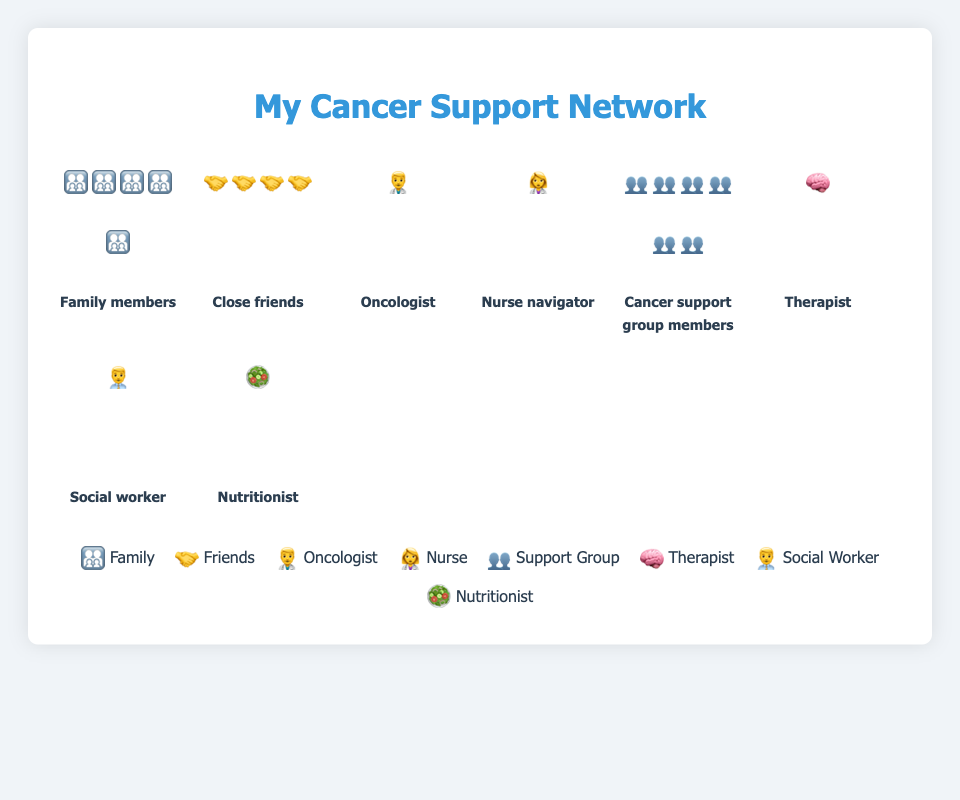How many family members are depicted in the plot? The plot shows five icons representing family members. You can count the icons labeled under "Family members."
Answer: 5 Which support network type has the highest count? By looking at the isotype plot, the "Cancer support group members" category has six icons, which is the highest count compared to other support types.
Answer: Cancer support group members What is the combined count of professional healthcare providers (Oncologist, Nurse navigator, Therapist, Social worker, Nutritionist)? Add the counts from the categories of Oncologist (1), Nurse navigator (1), Therapist (1), Social worker (1), and Nutritionist (1). 1 + 1 + 1 + 1 + 1 = 5.
Answer: 5 How does the number of close friends compare to family members? The figure shows four icons for close friends and five icons for family members. Since 4 < 5, there are fewer close friends than family members.
Answer: Fewer Which category has an equal number of icons to the Oncologist? Both the "Nurse navigator," the "Therapist," the "Social worker," and the "Nutritionist" categories have one icon each, which is equal to the icon count for "Oncologist."
Answer: Nurse navigator, Therapist, Social worker, Nutritionist How many support types have only one member depicted? By counting how many categories have one icon each, we find the Oncologist, Nurse navigator, Therapist, Social worker, and Nutritionist, making a total of 5 support types.
Answer: 5 What's the total number of icons present in the plot? Sum all icons across all categories: Family members (5) + Close friends (4) + Oncologist (1) + Nurse navigator (1) + Cancer support group members (6) + Therapist (1) + Social worker (1) + Nutritionist (1). 5 + 4 + 1 + 1 + 6 + 1 + 1 + 1 = 20
Answer: 20 What can be inferred about the number of healthcare professionals compared to non-professionals in the support network? Count the healthcare professionals (Oncologist, Nurse navigator, Therapist, Social worker, Nutritionist), which total to 5. Non-professional members (Family members, Close friends, Cancer support group members) total to 15 from counting their icons. Since 5 < 15, there are fewer healthcare professionals compared to non-professionals.
Answer: Fewer healthcare professionals How many more Cancer support group members are there than immediate healthcare professionals (Oncologist, Nurse navigator)? Compare the count of Cancer support group members (6) with Oncologist (1) and Nurse navigator (1). The difference is 6 - (1 + 1) = 4.
Answer: 4 